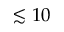Convert formula to latex. <formula><loc_0><loc_0><loc_500><loc_500>\lesssim 1 0</formula> 